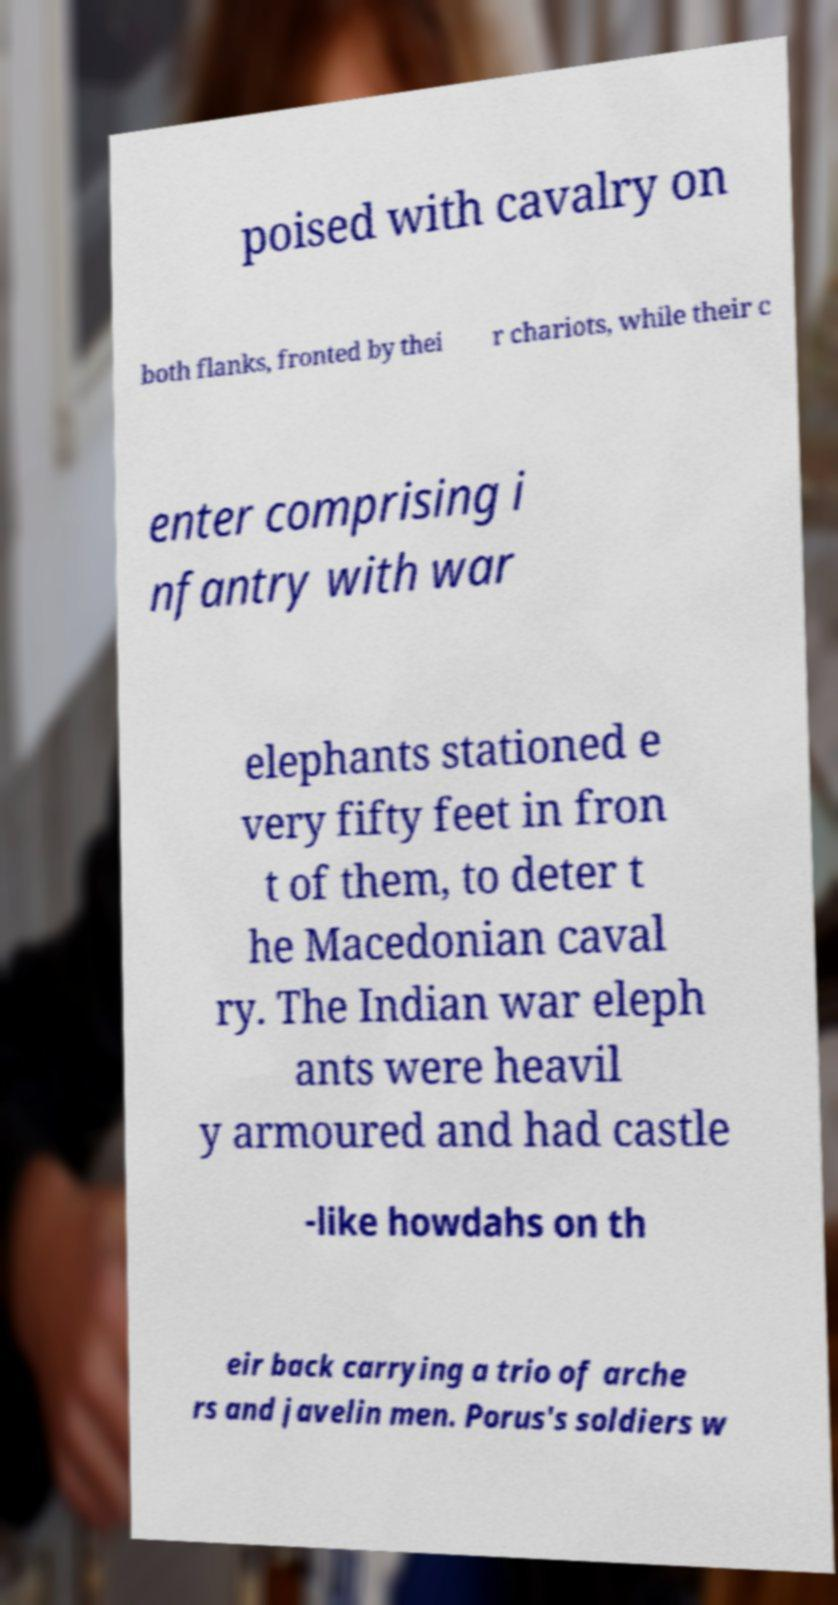For documentation purposes, I need the text within this image transcribed. Could you provide that? poised with cavalry on both flanks, fronted by thei r chariots, while their c enter comprising i nfantry with war elephants stationed e very fifty feet in fron t of them, to deter t he Macedonian caval ry. The Indian war eleph ants were heavil y armoured and had castle -like howdahs on th eir back carrying a trio of arche rs and javelin men. Porus's soldiers w 